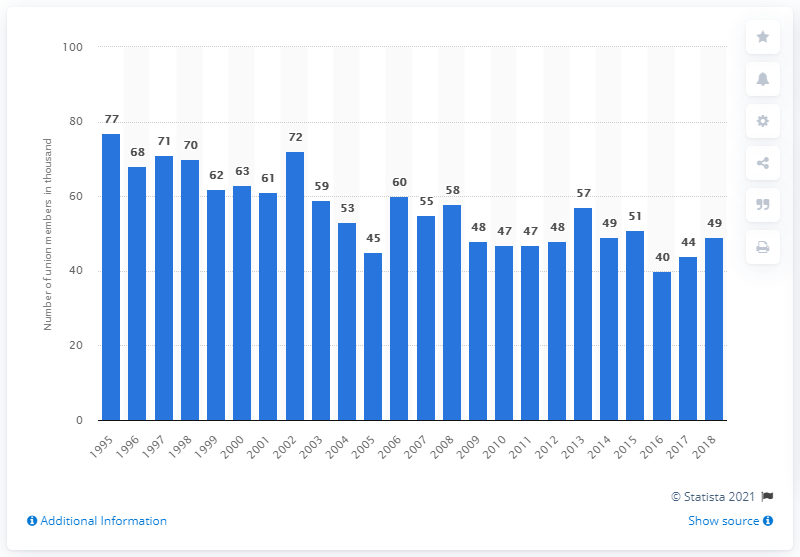Specify some key components in this picture. The number of trade union members in accommodation and food service activities in the UK peaked in 1995. 